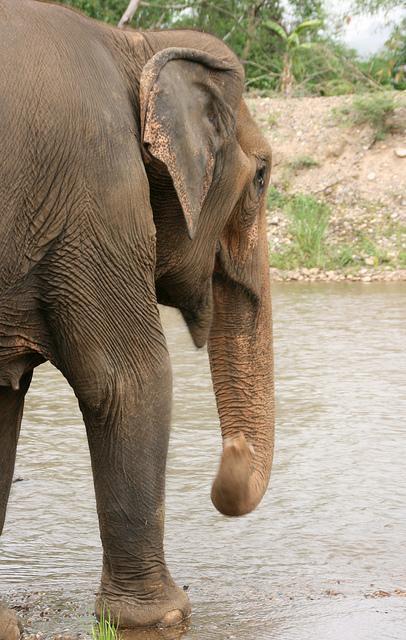How many legs can you see?
Give a very brief answer. 2. How many cats are sitting on the floor?
Give a very brief answer. 0. 